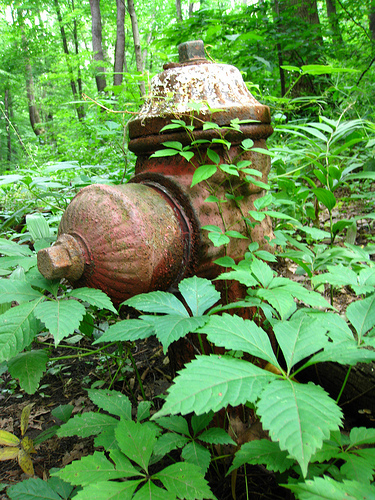Are there any glasses or fire hydrants in this picture? Yes, there is a fire hydrant visible in the picture, prominently surrounded by dense vegetation. 